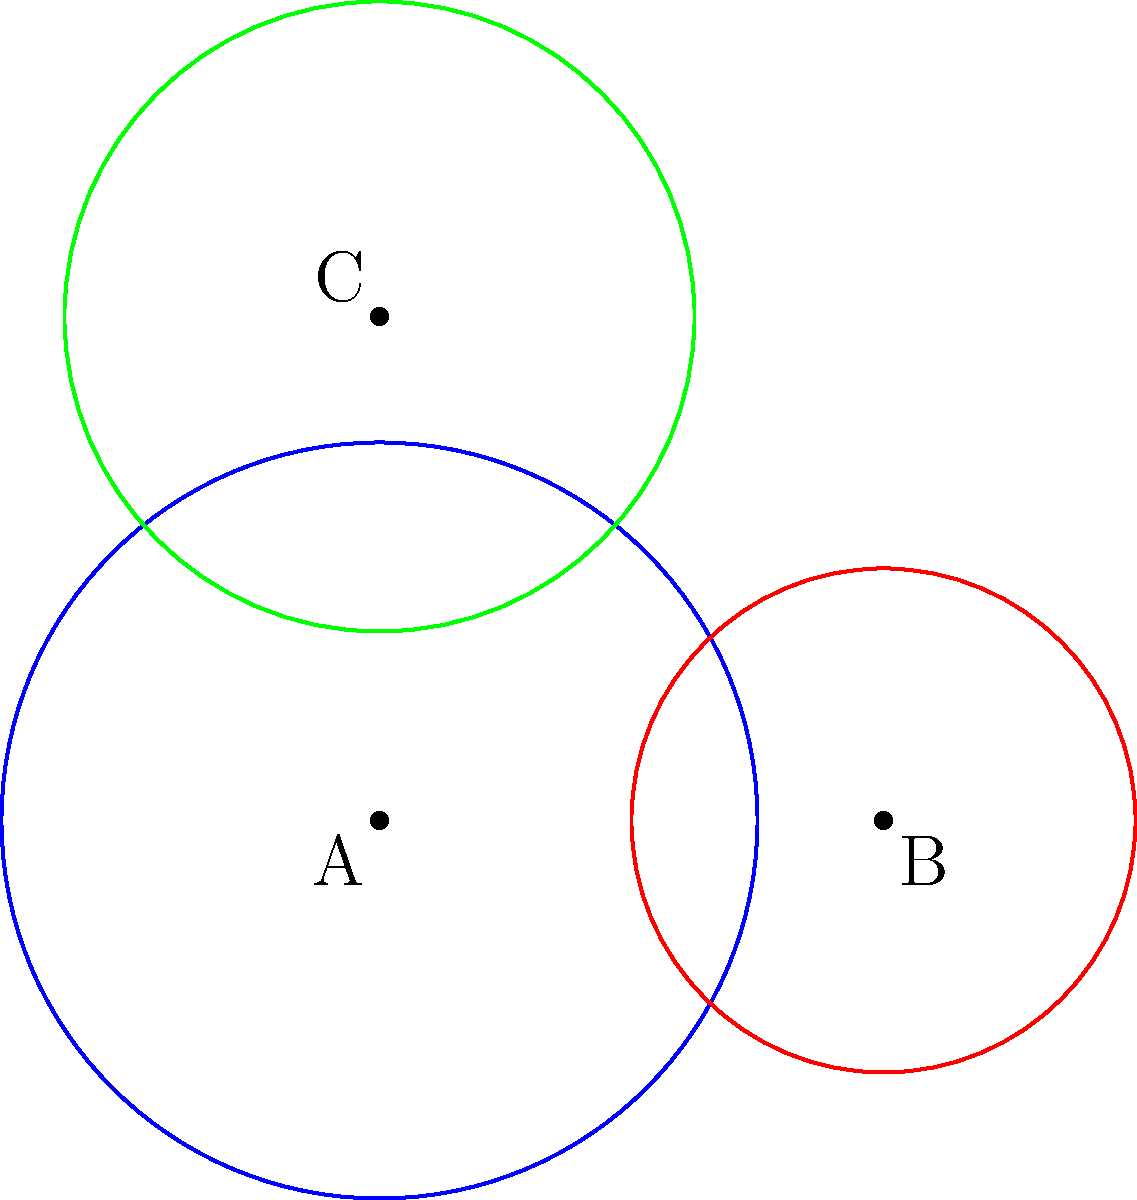In a study of cultural taboos, three circular regions A, B, and C represent different societal norms related to punishment. Circle A has a radius of 3 units, B has a radius of 2 units, and C has a radius of 2.5 units. The overlapping areas represent the consequences of violating multiple taboos simultaneously. If the total area of all three circles combined (including overlaps) is 42.5 square units, what is the area of the region where all three circles intersect? Let's approach this step-by-step:

1) First, we need to calculate the areas of each circle:
   Area of A: $A_A = \pi r_A^2 = \pi (3^2) = 9\pi$
   Area of B: $A_B = \pi r_B^2 = \pi (2^2) = 4\pi$
   Area of C: $A_C = \pi r_C^2 = \pi (2.5^2) = 6.25\pi$

2) The total area of all three circles individually is:
   $A_{\text{total individual}} = 9\pi + 4\pi + 6.25\pi = 19.25\pi$

3) We're given that the actual combined area (including overlaps) is 42.5 square units. Let's call this $A_{\text{combined}}$.

4) The difference between these areas represents the total overlapping area:
   $A_{\text{overlap}} = A_{\text{total individual}} - A_{\text{combined}} = 19.25\pi - 42.5$

5) Let's define:
   $x$ = area where all three circles intersect
   $a$ = area where only A and B intersect
   $b$ = area where only B and C intersect
   $c$ = area where only A and C intersect

6) We can write:
   $A_{\text{overlap}} = (a + b + c) + 2x$

7) Unfortunately, we don't have enough information to solve for $x$ directly. However, given the context of cultural taboos and their consequences, it's logical to assume that the area where all three intersect (the most severe consequence) would be relatively small.

8) A reasonable estimate, based on the diagram and the nature of overlapping circles, might be that $x$ is approximately 1/4 of the total overlap area.

9) Therefore:
   $x \approx \frac{1}{4} A_{\text{overlap}} = \frac{1}{4} (19.25\pi - 42.5) \approx 2.35$ square units

This is an approximate solution based on the given information and reasonable assumptions about the nature of cultural taboos and their consequences.
Answer: Approximately 2.35 square units 